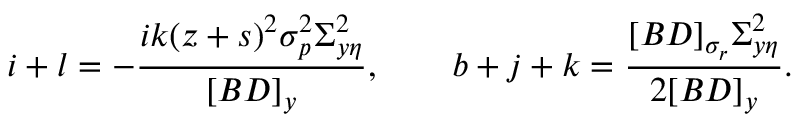Convert formula to latex. <formula><loc_0><loc_0><loc_500><loc_500>i + l = - \frac { i k ( z + s ) ^ { 2 } \sigma _ { p } ^ { 2 } \Sigma _ { y \eta } ^ { 2 } } { [ B D ] _ { y } } , \quad b + j + k = \frac { [ B D ] _ { \sigma _ { r } } \Sigma _ { y \eta } ^ { 2 } } { 2 [ B D ] _ { y } } .</formula> 